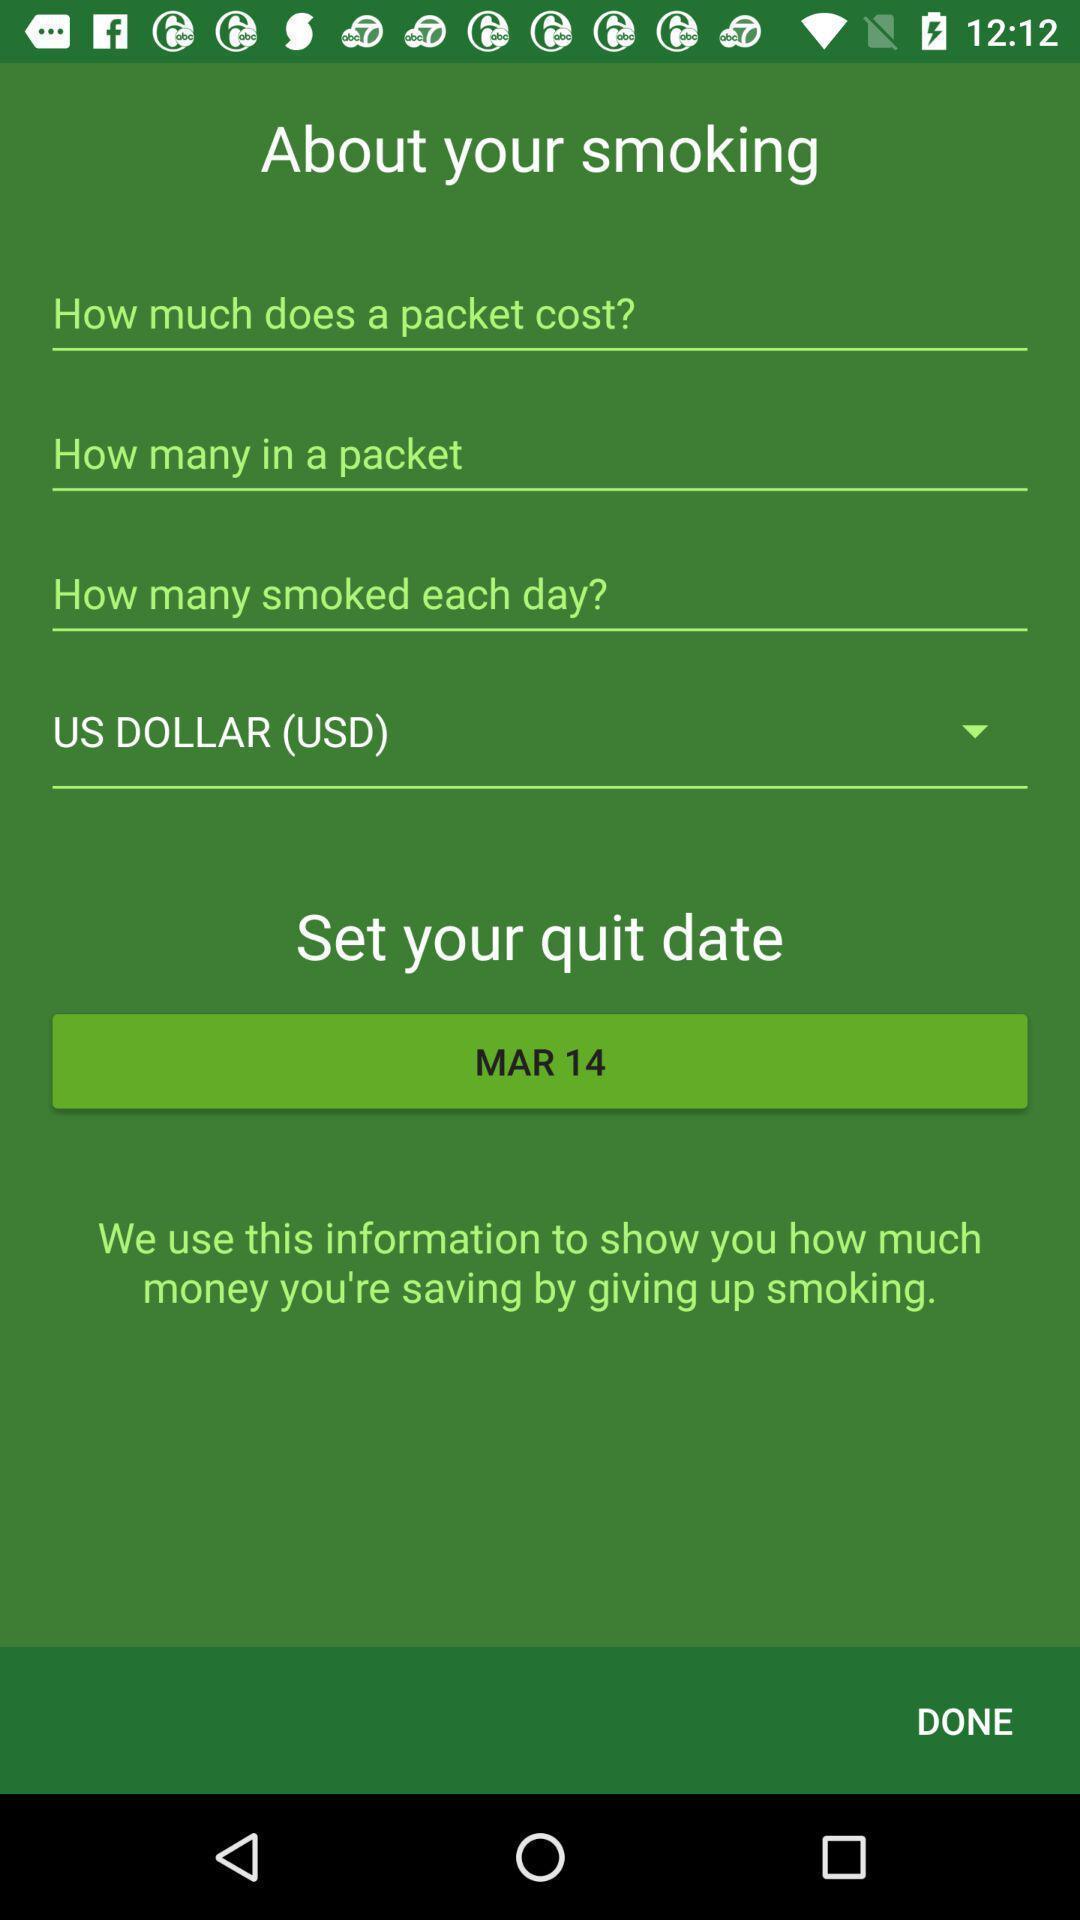What is the overall content of this screenshot? Page displaying various options about smoking. 